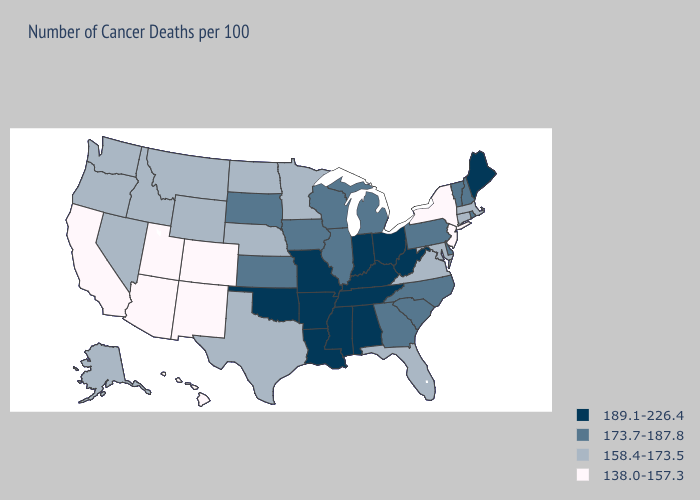What is the lowest value in the MidWest?
Write a very short answer. 158.4-173.5. Does West Virginia have the highest value in the South?
Keep it brief. Yes. What is the highest value in states that border Florida?
Keep it brief. 189.1-226.4. Does the map have missing data?
Keep it brief. No. What is the value of Hawaii?
Concise answer only. 138.0-157.3. Does Arizona have the highest value in the West?
Give a very brief answer. No. Name the states that have a value in the range 173.7-187.8?
Give a very brief answer. Delaware, Georgia, Illinois, Iowa, Kansas, Michigan, New Hampshire, North Carolina, Pennsylvania, Rhode Island, South Carolina, South Dakota, Vermont, Wisconsin. What is the value of New Mexico?
Give a very brief answer. 138.0-157.3. Name the states that have a value in the range 138.0-157.3?
Concise answer only. Arizona, California, Colorado, Hawaii, New Jersey, New Mexico, New York, Utah. Does Washington have the lowest value in the USA?
Be succinct. No. What is the lowest value in states that border Nebraska?
Answer briefly. 138.0-157.3. What is the value of Massachusetts?
Give a very brief answer. 158.4-173.5. Name the states that have a value in the range 173.7-187.8?
Answer briefly. Delaware, Georgia, Illinois, Iowa, Kansas, Michigan, New Hampshire, North Carolina, Pennsylvania, Rhode Island, South Carolina, South Dakota, Vermont, Wisconsin. Name the states that have a value in the range 173.7-187.8?
Be succinct. Delaware, Georgia, Illinois, Iowa, Kansas, Michigan, New Hampshire, North Carolina, Pennsylvania, Rhode Island, South Carolina, South Dakota, Vermont, Wisconsin. Name the states that have a value in the range 158.4-173.5?
Answer briefly. Alaska, Connecticut, Florida, Idaho, Maryland, Massachusetts, Minnesota, Montana, Nebraska, Nevada, North Dakota, Oregon, Texas, Virginia, Washington, Wyoming. 